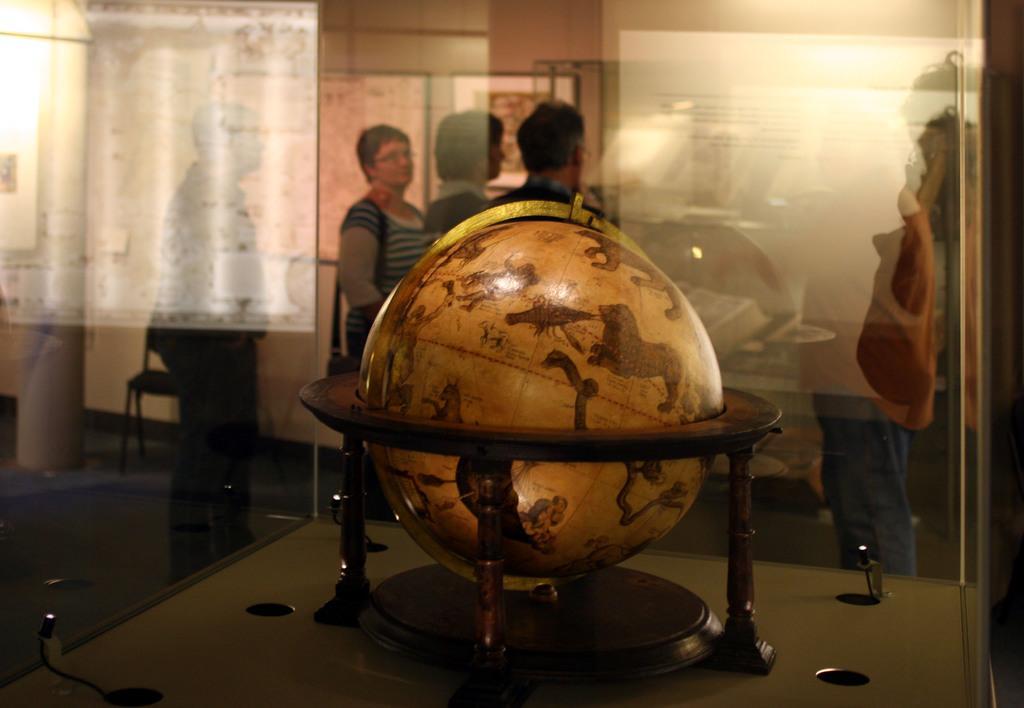How would you summarize this image in a sentence or two? In this image I can see a globe in a glass box. In the background there are few people standing , there is a chair and there are photo frames attached to the wall. 